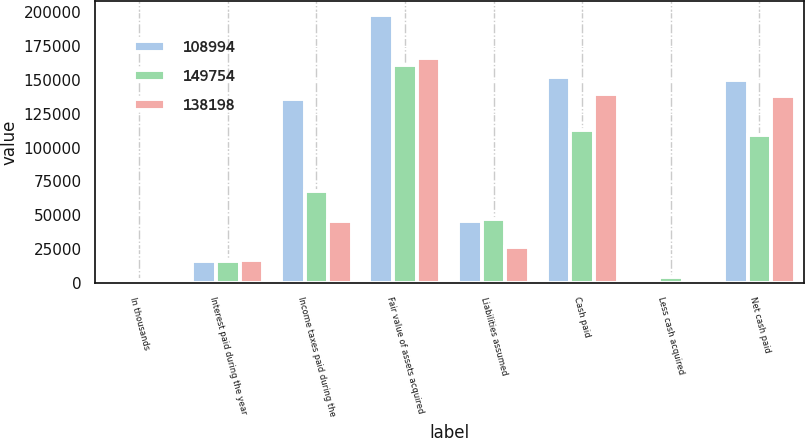<chart> <loc_0><loc_0><loc_500><loc_500><stacked_bar_chart><ecel><fcel>In thousands<fcel>Interest paid during the year<fcel>Income taxes paid during the<fcel>Fair value of assets acquired<fcel>Liabilities assumed<fcel>Cash paid<fcel>Less cash acquired<fcel>Net cash paid<nl><fcel>108994<fcel>2012<fcel>16309<fcel>135691<fcel>198066<fcel>46009<fcel>152057<fcel>2303<fcel>149754<nl><fcel>149754<fcel>2011<fcel>16505<fcel>68053<fcel>160862<fcel>47620<fcel>113242<fcel>4248<fcel>108994<nl><fcel>138198<fcel>2010<fcel>16814<fcel>46106<fcel>166048<fcel>26280<fcel>139768<fcel>1570<fcel>138198<nl></chart> 